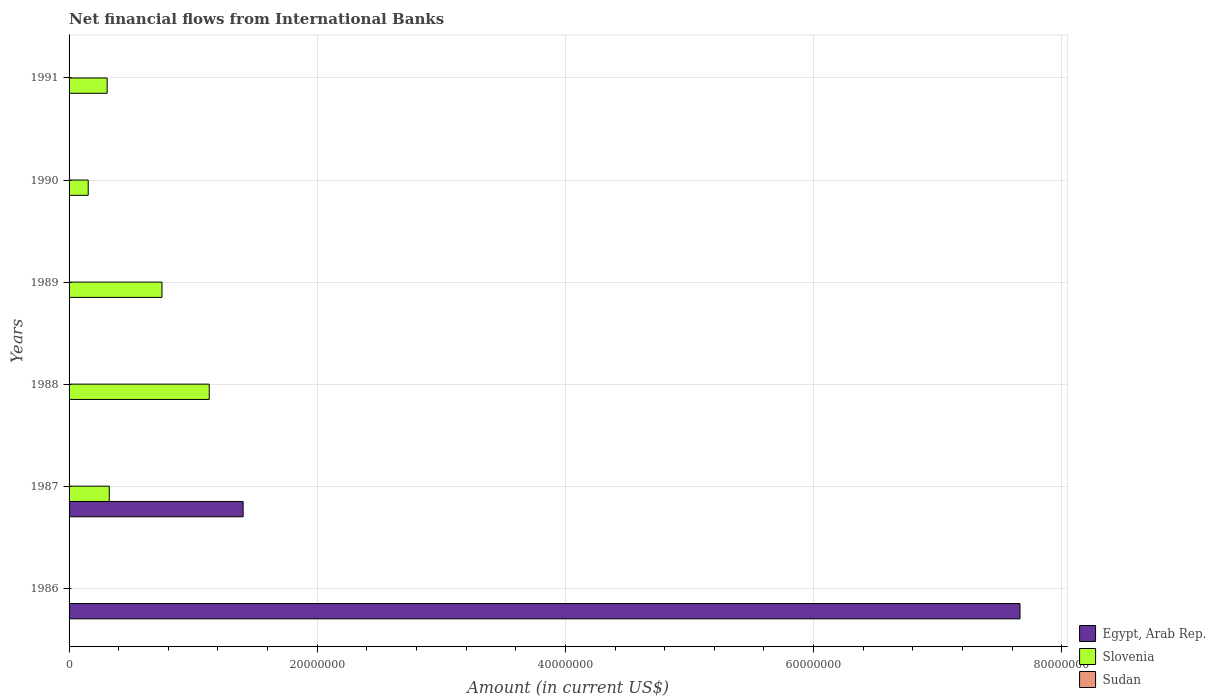Are the number of bars per tick equal to the number of legend labels?
Offer a very short reply. No. Are the number of bars on each tick of the Y-axis equal?
Keep it short and to the point. No. In how many cases, is the number of bars for a given year not equal to the number of legend labels?
Offer a very short reply. 6. Across all years, what is the maximum net financial aid flows in Slovenia?
Offer a terse response. 1.13e+07. Across all years, what is the minimum net financial aid flows in Slovenia?
Provide a succinct answer. 0. In which year was the net financial aid flows in Slovenia maximum?
Offer a very short reply. 1988. What is the total net financial aid flows in Slovenia in the graph?
Your response must be concise. 2.66e+07. What is the difference between the net financial aid flows in Egypt, Arab Rep. in 1986 and that in 1987?
Make the answer very short. 6.26e+07. What is the difference between the net financial aid flows in Sudan in 1989 and the net financial aid flows in Egypt, Arab Rep. in 1986?
Ensure brevity in your answer.  -7.66e+07. What is the average net financial aid flows in Egypt, Arab Rep. per year?
Ensure brevity in your answer.  1.51e+07. In the year 1987, what is the difference between the net financial aid flows in Slovenia and net financial aid flows in Egypt, Arab Rep.?
Your answer should be compact. -1.08e+07. What is the difference between the highest and the second highest net financial aid flows in Slovenia?
Your answer should be very brief. 3.81e+06. What is the difference between the highest and the lowest net financial aid flows in Egypt, Arab Rep.?
Give a very brief answer. 7.66e+07. How many years are there in the graph?
Offer a terse response. 6. What is the difference between two consecutive major ticks on the X-axis?
Your response must be concise. 2.00e+07. Does the graph contain any zero values?
Your answer should be compact. Yes. How many legend labels are there?
Keep it short and to the point. 3. How are the legend labels stacked?
Your response must be concise. Vertical. What is the title of the graph?
Offer a very short reply. Net financial flows from International Banks. Does "Portugal" appear as one of the legend labels in the graph?
Offer a terse response. No. What is the label or title of the Y-axis?
Offer a very short reply. Years. What is the Amount (in current US$) in Egypt, Arab Rep. in 1986?
Your response must be concise. 7.66e+07. What is the Amount (in current US$) in Slovenia in 1986?
Your response must be concise. 0. What is the Amount (in current US$) of Egypt, Arab Rep. in 1987?
Provide a succinct answer. 1.40e+07. What is the Amount (in current US$) of Slovenia in 1987?
Provide a short and direct response. 3.24e+06. What is the Amount (in current US$) in Egypt, Arab Rep. in 1988?
Provide a succinct answer. 0. What is the Amount (in current US$) of Slovenia in 1988?
Your response must be concise. 1.13e+07. What is the Amount (in current US$) in Slovenia in 1989?
Keep it short and to the point. 7.49e+06. What is the Amount (in current US$) of Slovenia in 1990?
Make the answer very short. 1.54e+06. What is the Amount (in current US$) in Egypt, Arab Rep. in 1991?
Your answer should be very brief. 0. What is the Amount (in current US$) in Slovenia in 1991?
Offer a very short reply. 3.07e+06. Across all years, what is the maximum Amount (in current US$) in Egypt, Arab Rep.?
Offer a terse response. 7.66e+07. Across all years, what is the maximum Amount (in current US$) in Slovenia?
Your response must be concise. 1.13e+07. Across all years, what is the minimum Amount (in current US$) of Slovenia?
Your response must be concise. 0. What is the total Amount (in current US$) in Egypt, Arab Rep. in the graph?
Offer a terse response. 9.07e+07. What is the total Amount (in current US$) of Slovenia in the graph?
Make the answer very short. 2.66e+07. What is the difference between the Amount (in current US$) of Egypt, Arab Rep. in 1986 and that in 1987?
Provide a succinct answer. 6.26e+07. What is the difference between the Amount (in current US$) in Slovenia in 1987 and that in 1988?
Your answer should be compact. -8.05e+06. What is the difference between the Amount (in current US$) of Slovenia in 1987 and that in 1989?
Keep it short and to the point. -4.25e+06. What is the difference between the Amount (in current US$) in Slovenia in 1987 and that in 1990?
Offer a terse response. 1.70e+06. What is the difference between the Amount (in current US$) of Slovenia in 1987 and that in 1991?
Make the answer very short. 1.72e+05. What is the difference between the Amount (in current US$) of Slovenia in 1988 and that in 1989?
Your answer should be very brief. 3.81e+06. What is the difference between the Amount (in current US$) of Slovenia in 1988 and that in 1990?
Your response must be concise. 9.75e+06. What is the difference between the Amount (in current US$) of Slovenia in 1988 and that in 1991?
Make the answer very short. 8.23e+06. What is the difference between the Amount (in current US$) of Slovenia in 1989 and that in 1990?
Make the answer very short. 5.94e+06. What is the difference between the Amount (in current US$) in Slovenia in 1989 and that in 1991?
Your answer should be compact. 4.42e+06. What is the difference between the Amount (in current US$) in Slovenia in 1990 and that in 1991?
Your response must be concise. -1.53e+06. What is the difference between the Amount (in current US$) in Egypt, Arab Rep. in 1986 and the Amount (in current US$) in Slovenia in 1987?
Provide a succinct answer. 7.34e+07. What is the difference between the Amount (in current US$) of Egypt, Arab Rep. in 1986 and the Amount (in current US$) of Slovenia in 1988?
Your answer should be compact. 6.53e+07. What is the difference between the Amount (in current US$) in Egypt, Arab Rep. in 1986 and the Amount (in current US$) in Slovenia in 1989?
Ensure brevity in your answer.  6.91e+07. What is the difference between the Amount (in current US$) of Egypt, Arab Rep. in 1986 and the Amount (in current US$) of Slovenia in 1990?
Give a very brief answer. 7.51e+07. What is the difference between the Amount (in current US$) in Egypt, Arab Rep. in 1986 and the Amount (in current US$) in Slovenia in 1991?
Your response must be concise. 7.36e+07. What is the difference between the Amount (in current US$) in Egypt, Arab Rep. in 1987 and the Amount (in current US$) in Slovenia in 1988?
Offer a very short reply. 2.73e+06. What is the difference between the Amount (in current US$) of Egypt, Arab Rep. in 1987 and the Amount (in current US$) of Slovenia in 1989?
Your answer should be very brief. 6.54e+06. What is the difference between the Amount (in current US$) of Egypt, Arab Rep. in 1987 and the Amount (in current US$) of Slovenia in 1990?
Ensure brevity in your answer.  1.25e+07. What is the difference between the Amount (in current US$) of Egypt, Arab Rep. in 1987 and the Amount (in current US$) of Slovenia in 1991?
Offer a very short reply. 1.10e+07. What is the average Amount (in current US$) of Egypt, Arab Rep. per year?
Provide a succinct answer. 1.51e+07. What is the average Amount (in current US$) of Slovenia per year?
Offer a terse response. 4.44e+06. What is the average Amount (in current US$) of Sudan per year?
Provide a short and direct response. 0. In the year 1987, what is the difference between the Amount (in current US$) of Egypt, Arab Rep. and Amount (in current US$) of Slovenia?
Offer a very short reply. 1.08e+07. What is the ratio of the Amount (in current US$) in Egypt, Arab Rep. in 1986 to that in 1987?
Make the answer very short. 5.46. What is the ratio of the Amount (in current US$) of Slovenia in 1987 to that in 1988?
Offer a terse response. 0.29. What is the ratio of the Amount (in current US$) in Slovenia in 1987 to that in 1989?
Your answer should be very brief. 0.43. What is the ratio of the Amount (in current US$) of Slovenia in 1987 to that in 1990?
Provide a short and direct response. 2.1. What is the ratio of the Amount (in current US$) in Slovenia in 1987 to that in 1991?
Your response must be concise. 1.06. What is the ratio of the Amount (in current US$) of Slovenia in 1988 to that in 1989?
Your answer should be compact. 1.51. What is the ratio of the Amount (in current US$) of Slovenia in 1988 to that in 1990?
Offer a very short reply. 7.32. What is the ratio of the Amount (in current US$) of Slovenia in 1988 to that in 1991?
Provide a short and direct response. 3.68. What is the ratio of the Amount (in current US$) in Slovenia in 1989 to that in 1990?
Provide a short and direct response. 4.85. What is the ratio of the Amount (in current US$) in Slovenia in 1989 to that in 1991?
Make the answer very short. 2.44. What is the ratio of the Amount (in current US$) in Slovenia in 1990 to that in 1991?
Offer a very short reply. 0.5. What is the difference between the highest and the second highest Amount (in current US$) of Slovenia?
Give a very brief answer. 3.81e+06. What is the difference between the highest and the lowest Amount (in current US$) in Egypt, Arab Rep.?
Your response must be concise. 7.66e+07. What is the difference between the highest and the lowest Amount (in current US$) in Slovenia?
Your answer should be compact. 1.13e+07. 